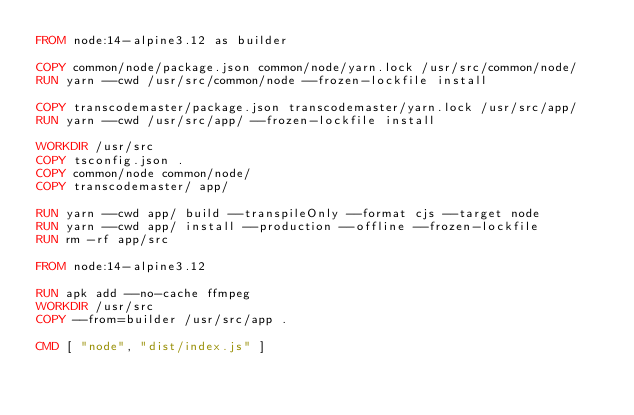<code> <loc_0><loc_0><loc_500><loc_500><_Dockerfile_>FROM node:14-alpine3.12 as builder

COPY common/node/package.json common/node/yarn.lock /usr/src/common/node/
RUN yarn --cwd /usr/src/common/node --frozen-lockfile install

COPY transcodemaster/package.json transcodemaster/yarn.lock /usr/src/app/
RUN yarn --cwd /usr/src/app/ --frozen-lockfile install

WORKDIR /usr/src
COPY tsconfig.json .
COPY common/node common/node/
COPY transcodemaster/ app/

RUN yarn --cwd app/ build --transpileOnly --format cjs --target node
RUN yarn --cwd app/ install --production --offline --frozen-lockfile
RUN rm -rf app/src

FROM node:14-alpine3.12

RUN apk add --no-cache ffmpeg
WORKDIR /usr/src
COPY --from=builder /usr/src/app .

CMD [ "node", "dist/index.js" ]</code> 